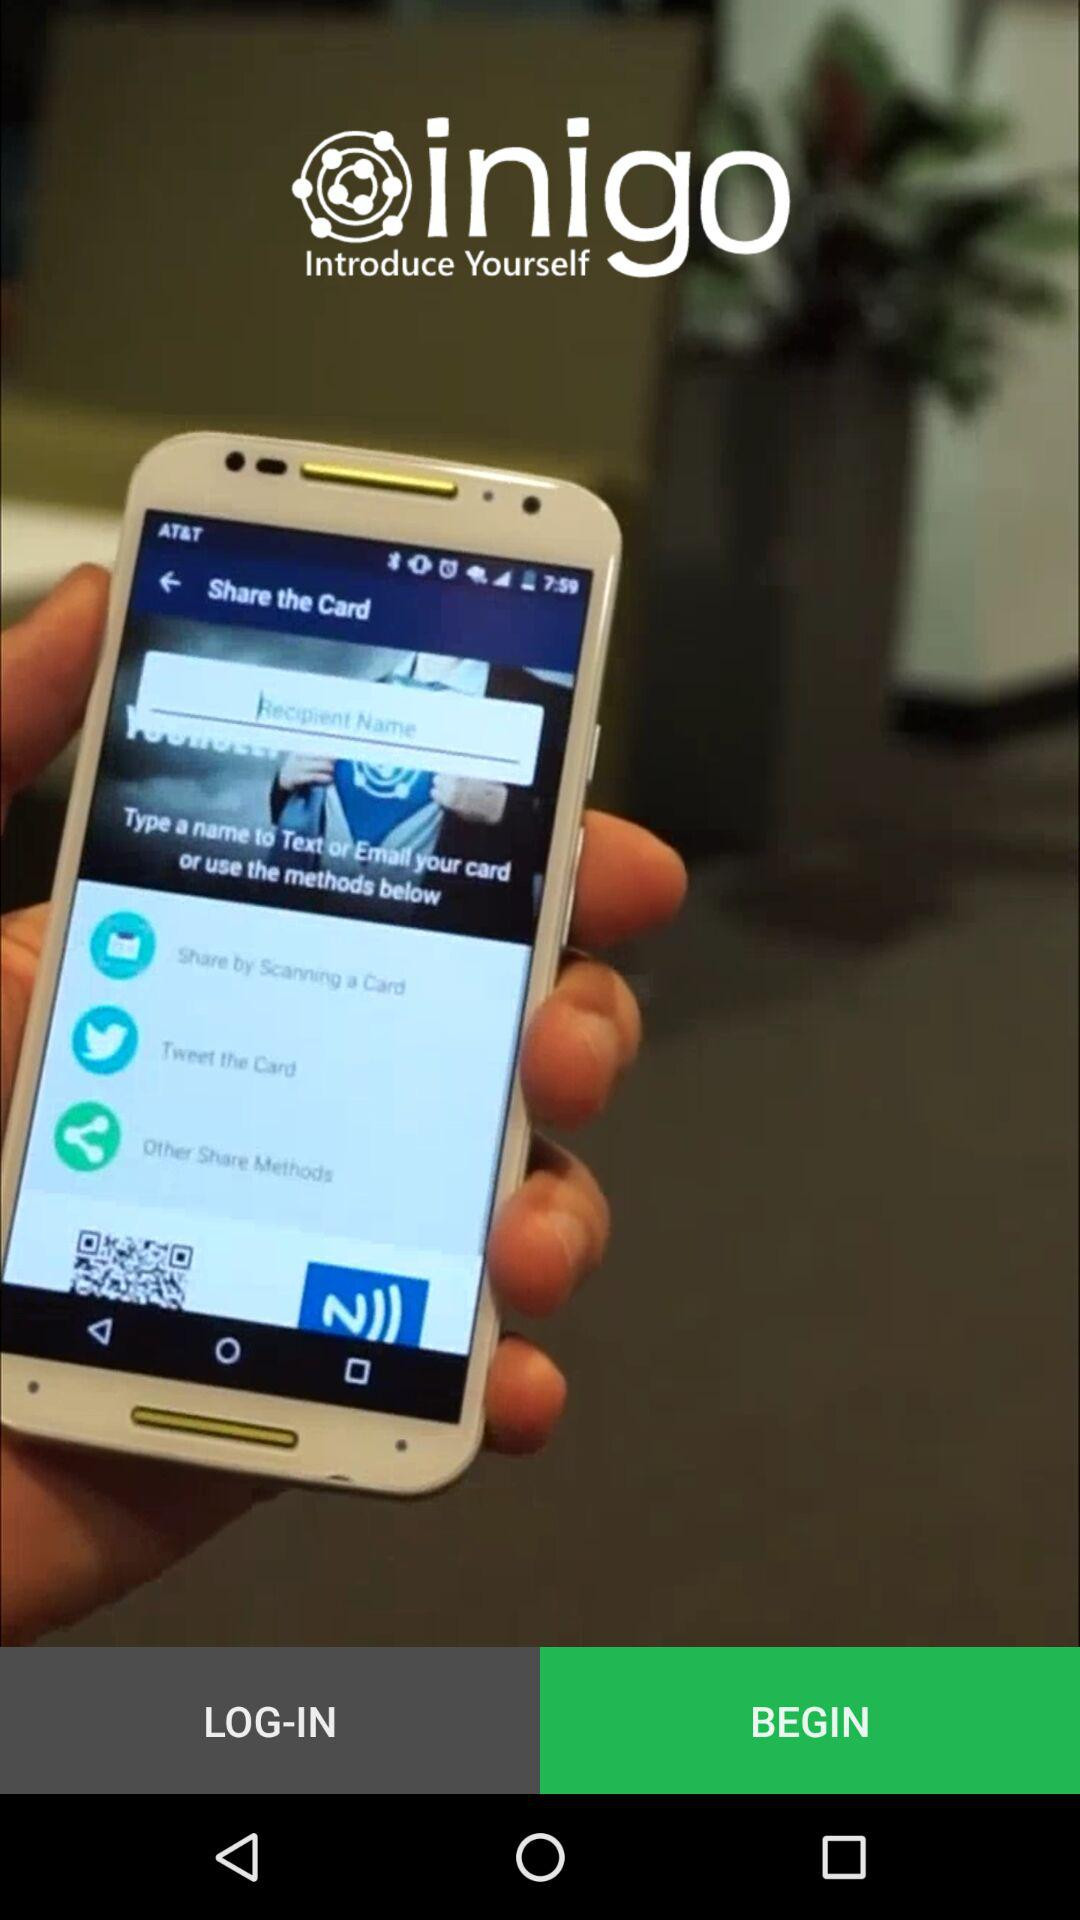Which Tab is selected? The selected tab in the image is 'Share the Card.' This can be identified by the visual emphasis and coloring seen surrounding the tab, distinguishing it from the other options. 